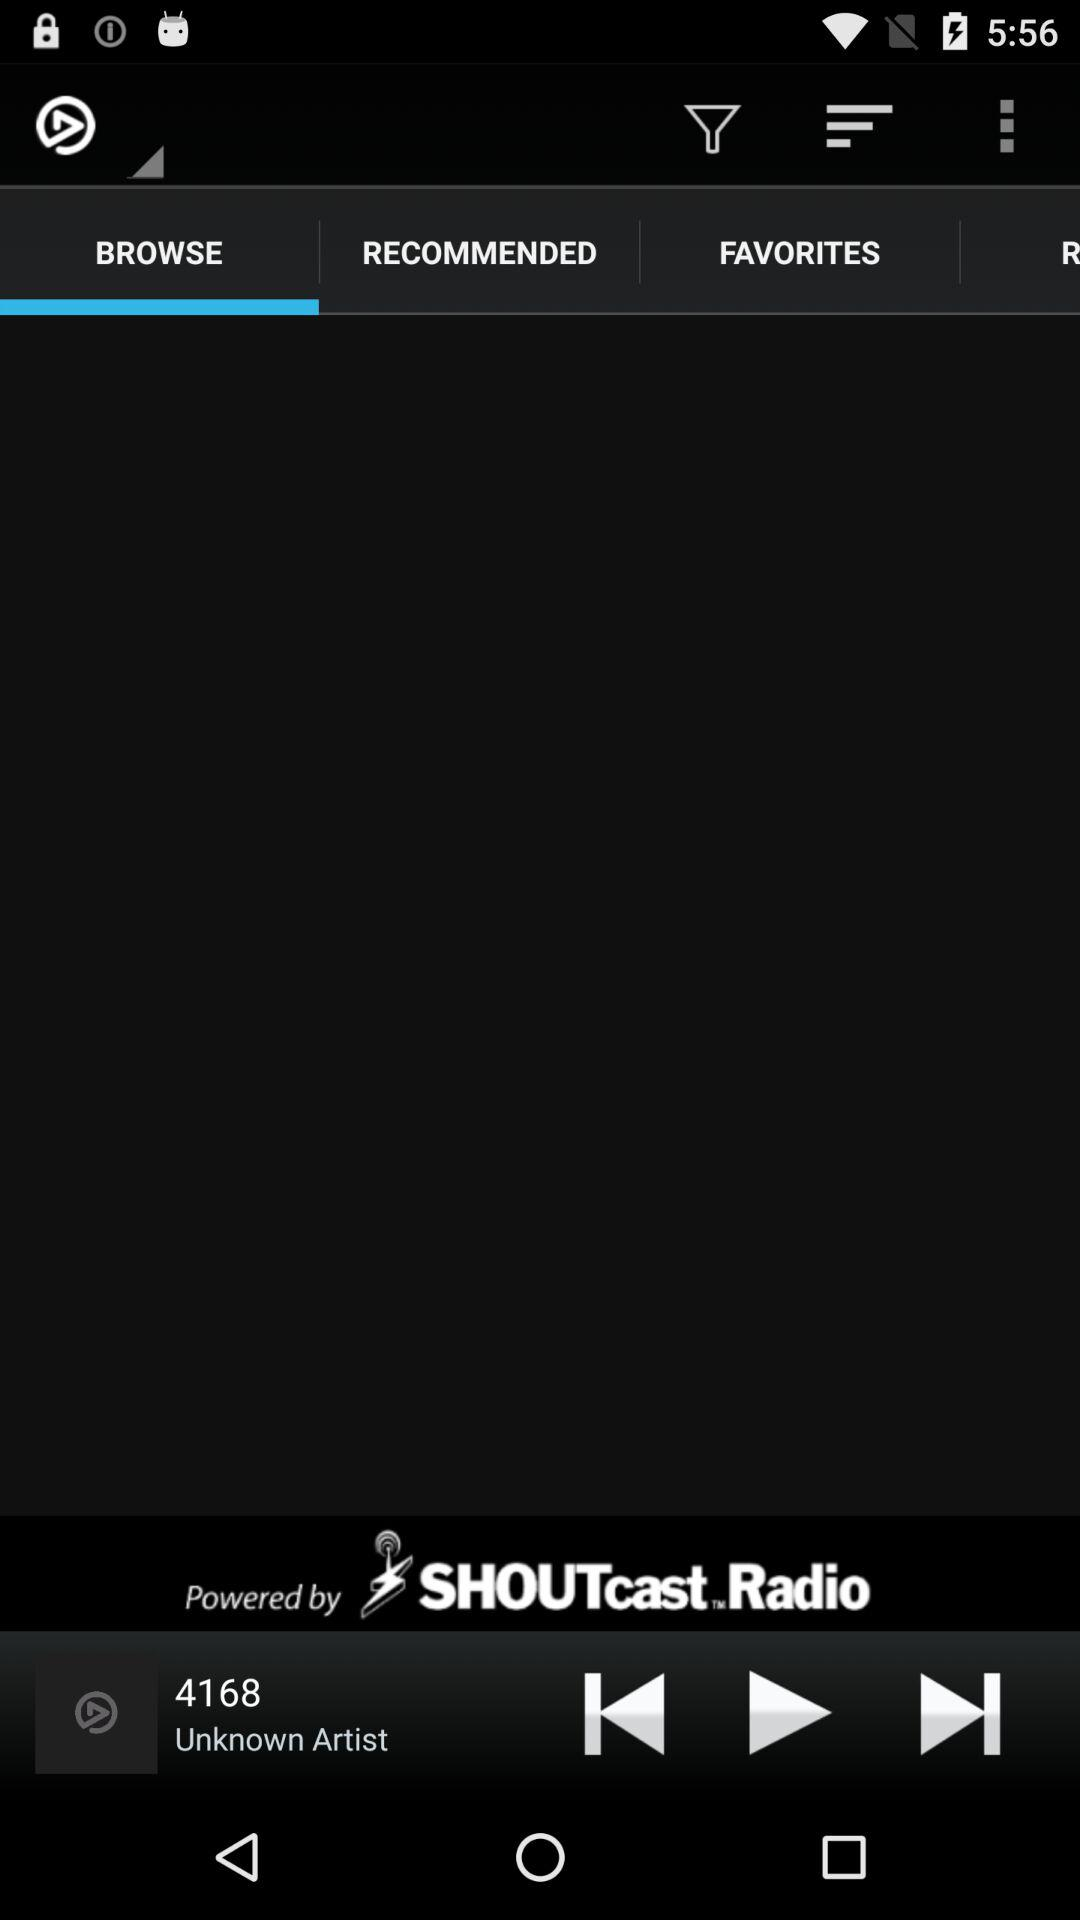Which tab is open? The open tab is "BROWSE". 